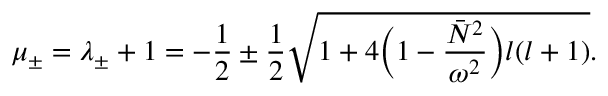<formula> <loc_0><loc_0><loc_500><loc_500>\mu _ { \pm } = \lambda _ { \pm } + 1 = - \frac { 1 } { 2 } \pm \frac { 1 } { 2 } \sqrt { 1 + 4 \left ( 1 - \frac { \bar { N } ^ { 2 } } { \omega ^ { 2 } } \right ) l ( l + 1 ) } .</formula> 